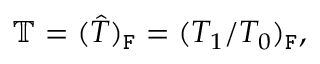Convert formula to latex. <formula><loc_0><loc_0><loc_500><loc_500>\mathbb { T } = ( \hat { T } ) _ { F } = ( T _ { 1 } / T _ { 0 } ) _ { F } ,</formula> 